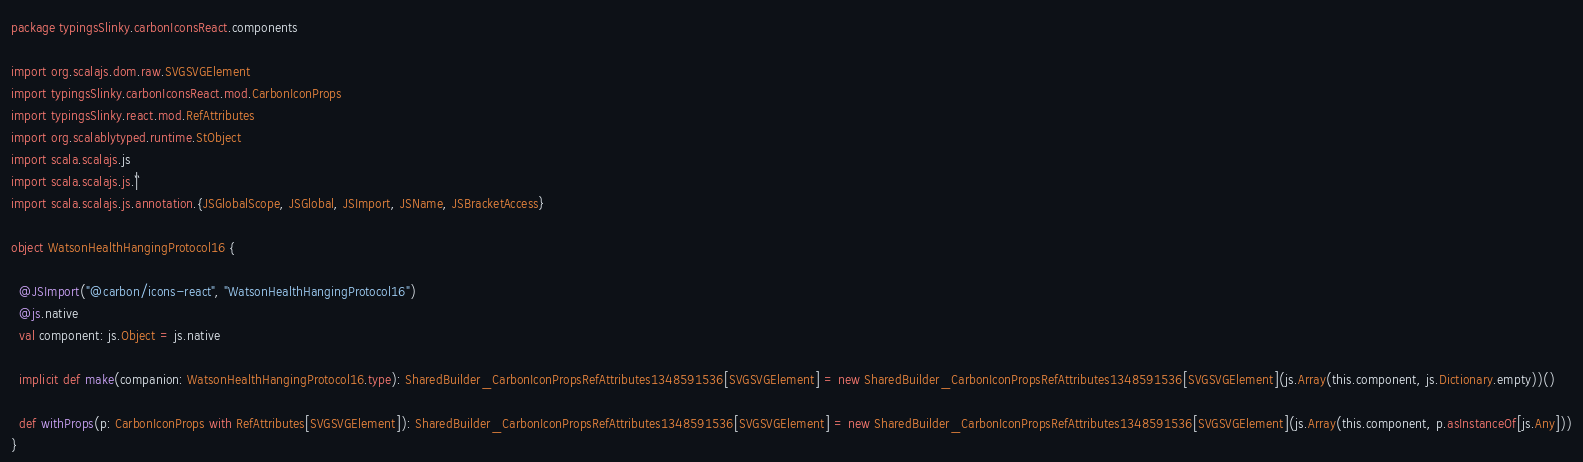<code> <loc_0><loc_0><loc_500><loc_500><_Scala_>package typingsSlinky.carbonIconsReact.components

import org.scalajs.dom.raw.SVGSVGElement
import typingsSlinky.carbonIconsReact.mod.CarbonIconProps
import typingsSlinky.react.mod.RefAttributes
import org.scalablytyped.runtime.StObject
import scala.scalajs.js
import scala.scalajs.js.`|`
import scala.scalajs.js.annotation.{JSGlobalScope, JSGlobal, JSImport, JSName, JSBracketAccess}

object WatsonHealthHangingProtocol16 {
  
  @JSImport("@carbon/icons-react", "WatsonHealthHangingProtocol16")
  @js.native
  val component: js.Object = js.native
  
  implicit def make(companion: WatsonHealthHangingProtocol16.type): SharedBuilder_CarbonIconPropsRefAttributes1348591536[SVGSVGElement] = new SharedBuilder_CarbonIconPropsRefAttributes1348591536[SVGSVGElement](js.Array(this.component, js.Dictionary.empty))()
  
  def withProps(p: CarbonIconProps with RefAttributes[SVGSVGElement]): SharedBuilder_CarbonIconPropsRefAttributes1348591536[SVGSVGElement] = new SharedBuilder_CarbonIconPropsRefAttributes1348591536[SVGSVGElement](js.Array(this.component, p.asInstanceOf[js.Any]))
}
</code> 